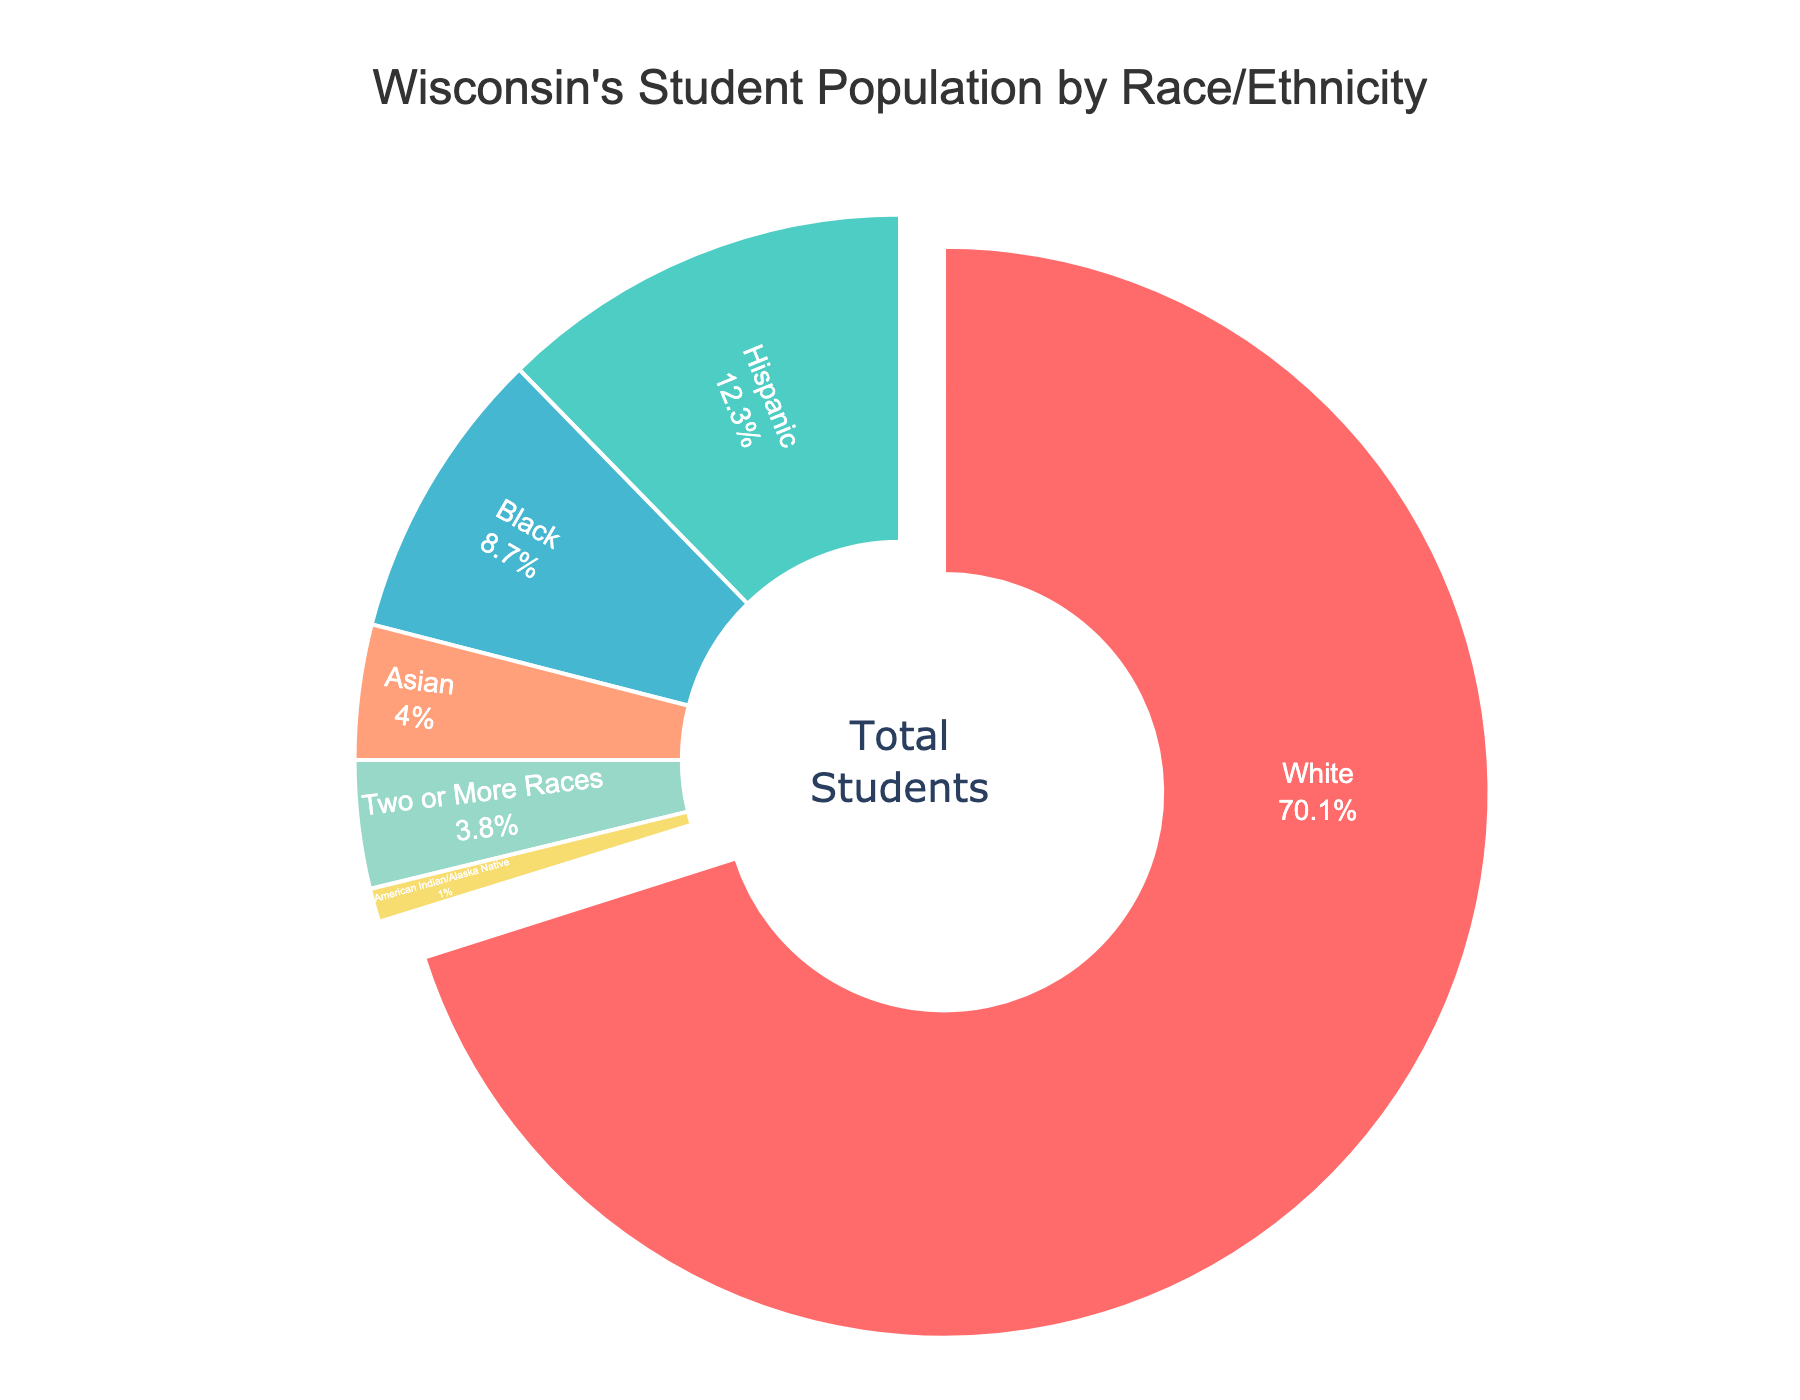What percentage of Wisconsin's student population is Asian and Hispanic combined? Add the percentages for Asian (4.0%) and Hispanic (12.3%). The combined percentage is 4.0% + 12.3% = 16.3%.
Answer: 16.3% Which racial/ethnic group has the smallest student population? Look for the segment with the smallest percentage. The Pacific Islander group has the smallest percentage at 0.1%.
Answer: Pacific Islander How much larger is the percentage of White students compared to Black students? Subtract the percentage of Black students (8.7%) from the percentage of White students (70.1%). The difference is 70.1% - 8.7% = 61.4%.
Answer: 61.4% Which group represents around 4% of the student population, other than Asian students? Look for a group with a percentage close to 4%. "Two or More Races" has a percentage of 3.8%, which is around 4%.
Answer: Two or More Races What colors are used to represent the racial/ethnic groups with percentages lower than 5%? Identify the colors corresponding to the groups: Asian (4.0% - light blue), Two or More Races (3.8% - light green), American Indian/Alaska Native (1.0% - yellow), Pacific Islander (0.1% - purple).
Answer: Light blue, light green, yellow, purple 